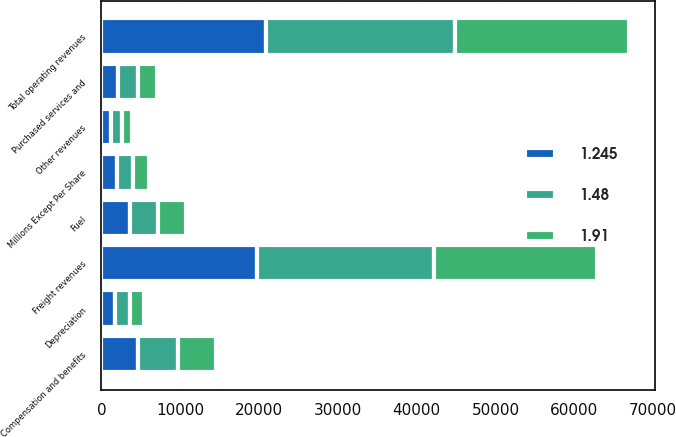<chart> <loc_0><loc_0><loc_500><loc_500><stacked_bar_chart><ecel><fcel>Millions Except Per Share<fcel>Freight revenues<fcel>Other revenues<fcel>Total operating revenues<fcel>Compensation and benefits<fcel>Fuel<fcel>Purchased services and<fcel>Depreciation<nl><fcel>1.48<fcel>2014<fcel>22560<fcel>1428<fcel>23988<fcel>5076<fcel>3539<fcel>2558<fcel>1904<nl><fcel>1.91<fcel>2013<fcel>20684<fcel>1279<fcel>21963<fcel>4807<fcel>3534<fcel>2315<fcel>1777<nl><fcel>1.245<fcel>2012<fcel>19686<fcel>1240<fcel>20926<fcel>4685<fcel>3608<fcel>2143<fcel>1760<nl></chart> 